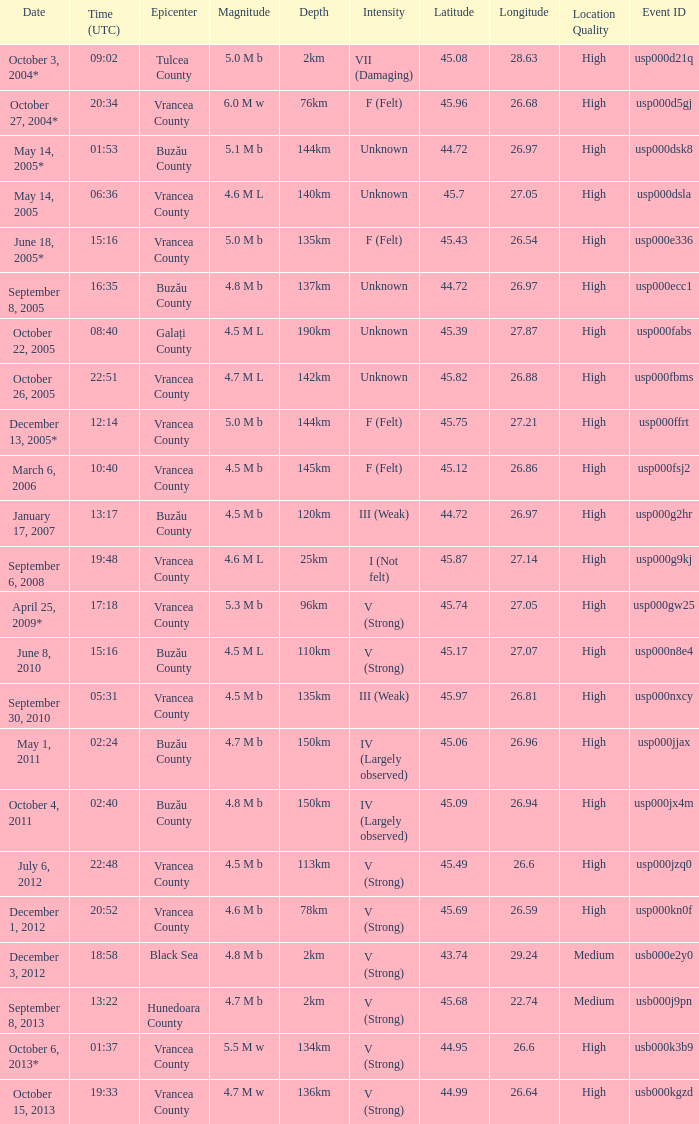Where was the epicenter of the quake on December 1, 2012? Vrancea County. 